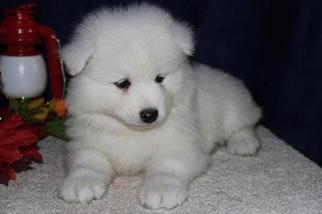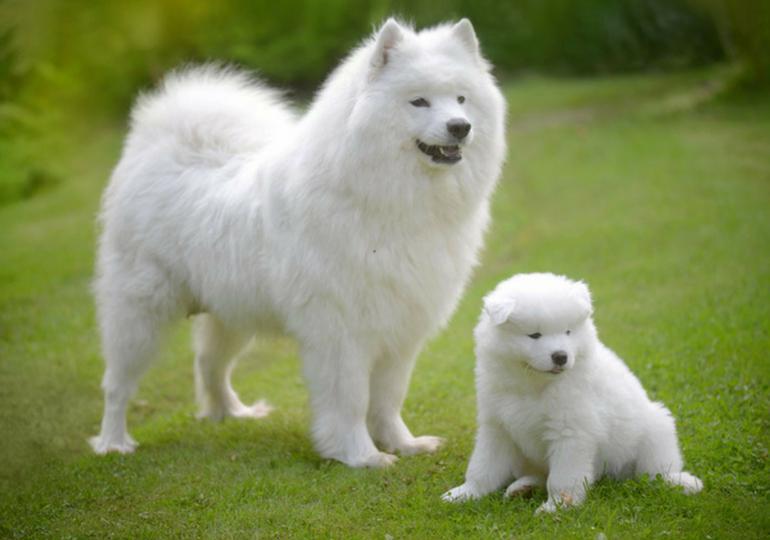The first image is the image on the left, the second image is the image on the right. Assess this claim about the two images: "One of the images shows an adult dog with a puppy on the grass.". Correct or not? Answer yes or no. Yes. The first image is the image on the left, the second image is the image on the right. Evaluate the accuracy of this statement regarding the images: "One image shows a small white pup next to a big white dog on green grass, and the other image contains exactly one white pup on a white surface.". Is it true? Answer yes or no. Yes. 